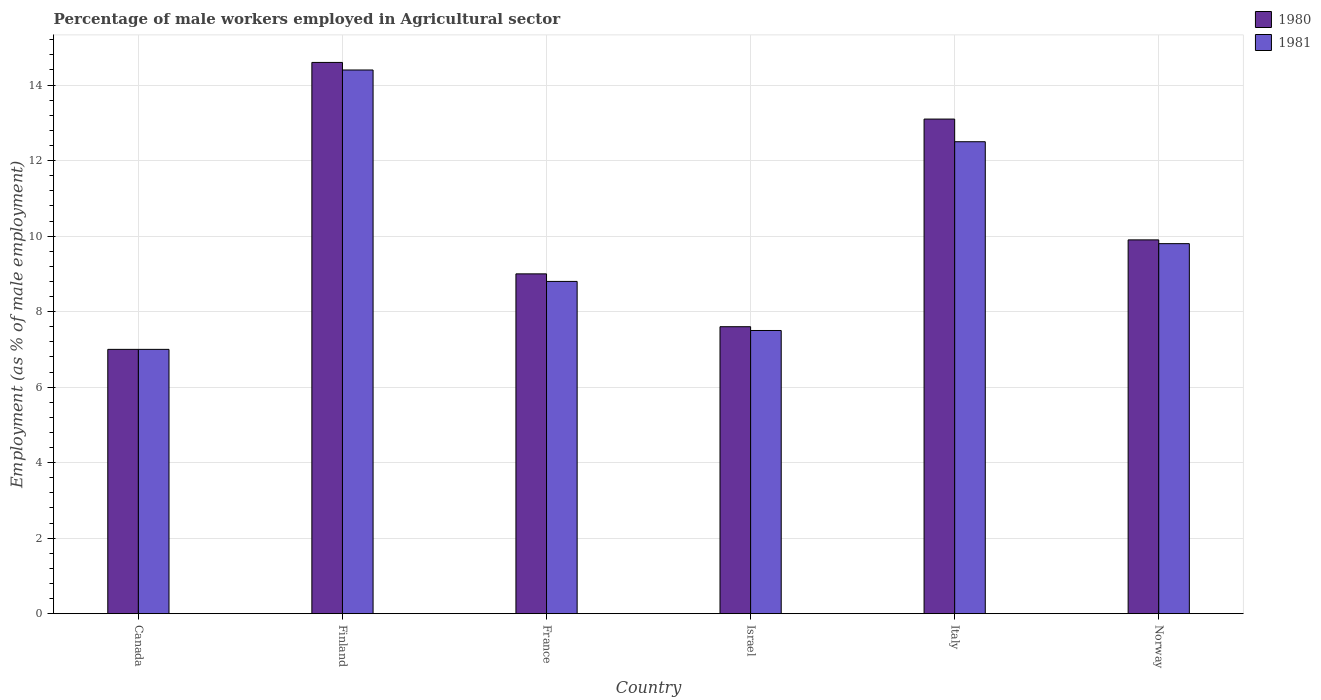Are the number of bars on each tick of the X-axis equal?
Your answer should be compact. Yes. How many bars are there on the 3rd tick from the left?
Keep it short and to the point. 2. How many bars are there on the 6th tick from the right?
Make the answer very short. 2. What is the label of the 5th group of bars from the left?
Provide a succinct answer. Italy. What is the percentage of male workers employed in Agricultural sector in 1980 in Norway?
Ensure brevity in your answer.  9.9. Across all countries, what is the maximum percentage of male workers employed in Agricultural sector in 1980?
Your response must be concise. 14.6. What is the total percentage of male workers employed in Agricultural sector in 1980 in the graph?
Keep it short and to the point. 61.2. What is the difference between the percentage of male workers employed in Agricultural sector in 1980 in Israel and that in Italy?
Provide a succinct answer. -5.5. What is the difference between the percentage of male workers employed in Agricultural sector in 1980 in Norway and the percentage of male workers employed in Agricultural sector in 1981 in Canada?
Your answer should be compact. 2.9. What is the average percentage of male workers employed in Agricultural sector in 1980 per country?
Provide a short and direct response. 10.2. What is the difference between the percentage of male workers employed in Agricultural sector of/in 1981 and percentage of male workers employed in Agricultural sector of/in 1980 in Italy?
Ensure brevity in your answer.  -0.6. What is the ratio of the percentage of male workers employed in Agricultural sector in 1981 in Canada to that in Norway?
Provide a short and direct response. 0.71. Is the percentage of male workers employed in Agricultural sector in 1981 in Israel less than that in Italy?
Offer a terse response. Yes. Is the difference between the percentage of male workers employed in Agricultural sector in 1981 in Canada and Finland greater than the difference between the percentage of male workers employed in Agricultural sector in 1980 in Canada and Finland?
Ensure brevity in your answer.  Yes. What is the difference between the highest and the second highest percentage of male workers employed in Agricultural sector in 1981?
Give a very brief answer. -2.7. What is the difference between the highest and the lowest percentage of male workers employed in Agricultural sector in 1981?
Your answer should be very brief. 7.4. In how many countries, is the percentage of male workers employed in Agricultural sector in 1980 greater than the average percentage of male workers employed in Agricultural sector in 1980 taken over all countries?
Provide a short and direct response. 2. What does the 2nd bar from the right in Canada represents?
Your answer should be very brief. 1980. How many bars are there?
Keep it short and to the point. 12. Are all the bars in the graph horizontal?
Offer a terse response. No. How many countries are there in the graph?
Your answer should be compact. 6. What is the difference between two consecutive major ticks on the Y-axis?
Your response must be concise. 2. Are the values on the major ticks of Y-axis written in scientific E-notation?
Your response must be concise. No. Does the graph contain any zero values?
Make the answer very short. No. Does the graph contain grids?
Your response must be concise. Yes. Where does the legend appear in the graph?
Your answer should be very brief. Top right. What is the title of the graph?
Keep it short and to the point. Percentage of male workers employed in Agricultural sector. What is the label or title of the Y-axis?
Provide a succinct answer. Employment (as % of male employment). What is the Employment (as % of male employment) in 1981 in Canada?
Give a very brief answer. 7. What is the Employment (as % of male employment) in 1980 in Finland?
Keep it short and to the point. 14.6. What is the Employment (as % of male employment) in 1981 in Finland?
Ensure brevity in your answer.  14.4. What is the Employment (as % of male employment) of 1980 in France?
Your answer should be compact. 9. What is the Employment (as % of male employment) of 1981 in France?
Your answer should be very brief. 8.8. What is the Employment (as % of male employment) in 1980 in Israel?
Ensure brevity in your answer.  7.6. What is the Employment (as % of male employment) in 1980 in Italy?
Your answer should be compact. 13.1. What is the Employment (as % of male employment) in 1981 in Italy?
Make the answer very short. 12.5. What is the Employment (as % of male employment) of 1980 in Norway?
Provide a short and direct response. 9.9. What is the Employment (as % of male employment) in 1981 in Norway?
Offer a very short reply. 9.8. Across all countries, what is the maximum Employment (as % of male employment) in 1980?
Make the answer very short. 14.6. Across all countries, what is the maximum Employment (as % of male employment) in 1981?
Provide a short and direct response. 14.4. What is the total Employment (as % of male employment) in 1980 in the graph?
Provide a short and direct response. 61.2. What is the total Employment (as % of male employment) of 1981 in the graph?
Provide a short and direct response. 60. What is the difference between the Employment (as % of male employment) in 1980 in Canada and that in France?
Provide a short and direct response. -2. What is the difference between the Employment (as % of male employment) of 1981 in Canada and that in France?
Your answer should be very brief. -1.8. What is the difference between the Employment (as % of male employment) of 1980 in Canada and that in Israel?
Your response must be concise. -0.6. What is the difference between the Employment (as % of male employment) of 1981 in Canada and that in Israel?
Your answer should be compact. -0.5. What is the difference between the Employment (as % of male employment) in 1981 in Canada and that in Norway?
Provide a succinct answer. -2.8. What is the difference between the Employment (as % of male employment) in 1980 in Finland and that in France?
Ensure brevity in your answer.  5.6. What is the difference between the Employment (as % of male employment) of 1981 in Finland and that in Israel?
Your response must be concise. 6.9. What is the difference between the Employment (as % of male employment) in 1980 in France and that in Israel?
Your response must be concise. 1.4. What is the difference between the Employment (as % of male employment) of 1981 in France and that in Israel?
Your answer should be very brief. 1.3. What is the difference between the Employment (as % of male employment) in 1980 in France and that in Italy?
Your answer should be very brief. -4.1. What is the difference between the Employment (as % of male employment) in 1980 in France and that in Norway?
Offer a very short reply. -0.9. What is the difference between the Employment (as % of male employment) in 1981 in Israel and that in Italy?
Your answer should be compact. -5. What is the difference between the Employment (as % of male employment) of 1980 in Israel and that in Norway?
Provide a succinct answer. -2.3. What is the difference between the Employment (as % of male employment) in 1981 in Israel and that in Norway?
Provide a succinct answer. -2.3. What is the difference between the Employment (as % of male employment) of 1981 in Italy and that in Norway?
Make the answer very short. 2.7. What is the difference between the Employment (as % of male employment) of 1980 in Canada and the Employment (as % of male employment) of 1981 in Italy?
Your answer should be very brief. -5.5. What is the difference between the Employment (as % of male employment) of 1980 in Finland and the Employment (as % of male employment) of 1981 in France?
Your answer should be very brief. 5.8. What is the difference between the Employment (as % of male employment) of 1980 in Finland and the Employment (as % of male employment) of 1981 in Israel?
Give a very brief answer. 7.1. What is the difference between the Employment (as % of male employment) in 1980 in France and the Employment (as % of male employment) in 1981 in Israel?
Offer a terse response. 1.5. What is the difference between the Employment (as % of male employment) in 1980 in France and the Employment (as % of male employment) in 1981 in Italy?
Provide a short and direct response. -3.5. What is the difference between the Employment (as % of male employment) of 1980 in France and the Employment (as % of male employment) of 1981 in Norway?
Provide a succinct answer. -0.8. What is the difference between the Employment (as % of male employment) in 1980 in Israel and the Employment (as % of male employment) in 1981 in Italy?
Offer a very short reply. -4.9. What is the difference between the Employment (as % of male employment) of 1980 in Israel and the Employment (as % of male employment) of 1981 in Norway?
Keep it short and to the point. -2.2. What is the difference between the Employment (as % of male employment) of 1980 and Employment (as % of male employment) of 1981 in Canada?
Your answer should be compact. 0. What is the difference between the Employment (as % of male employment) in 1980 and Employment (as % of male employment) in 1981 in Italy?
Provide a succinct answer. 0.6. What is the difference between the Employment (as % of male employment) in 1980 and Employment (as % of male employment) in 1981 in Norway?
Ensure brevity in your answer.  0.1. What is the ratio of the Employment (as % of male employment) of 1980 in Canada to that in Finland?
Your answer should be very brief. 0.48. What is the ratio of the Employment (as % of male employment) in 1981 in Canada to that in Finland?
Offer a terse response. 0.49. What is the ratio of the Employment (as % of male employment) in 1980 in Canada to that in France?
Make the answer very short. 0.78. What is the ratio of the Employment (as % of male employment) of 1981 in Canada to that in France?
Your answer should be very brief. 0.8. What is the ratio of the Employment (as % of male employment) in 1980 in Canada to that in Israel?
Your response must be concise. 0.92. What is the ratio of the Employment (as % of male employment) of 1981 in Canada to that in Israel?
Make the answer very short. 0.93. What is the ratio of the Employment (as % of male employment) of 1980 in Canada to that in Italy?
Keep it short and to the point. 0.53. What is the ratio of the Employment (as % of male employment) in 1981 in Canada to that in Italy?
Ensure brevity in your answer.  0.56. What is the ratio of the Employment (as % of male employment) in 1980 in Canada to that in Norway?
Provide a succinct answer. 0.71. What is the ratio of the Employment (as % of male employment) in 1980 in Finland to that in France?
Your answer should be compact. 1.62. What is the ratio of the Employment (as % of male employment) in 1981 in Finland to that in France?
Make the answer very short. 1.64. What is the ratio of the Employment (as % of male employment) in 1980 in Finland to that in Israel?
Offer a very short reply. 1.92. What is the ratio of the Employment (as % of male employment) of 1981 in Finland to that in Israel?
Ensure brevity in your answer.  1.92. What is the ratio of the Employment (as % of male employment) in 1980 in Finland to that in Italy?
Give a very brief answer. 1.11. What is the ratio of the Employment (as % of male employment) in 1981 in Finland to that in Italy?
Provide a succinct answer. 1.15. What is the ratio of the Employment (as % of male employment) of 1980 in Finland to that in Norway?
Offer a very short reply. 1.47. What is the ratio of the Employment (as % of male employment) of 1981 in Finland to that in Norway?
Give a very brief answer. 1.47. What is the ratio of the Employment (as % of male employment) in 1980 in France to that in Israel?
Ensure brevity in your answer.  1.18. What is the ratio of the Employment (as % of male employment) of 1981 in France to that in Israel?
Make the answer very short. 1.17. What is the ratio of the Employment (as % of male employment) in 1980 in France to that in Italy?
Ensure brevity in your answer.  0.69. What is the ratio of the Employment (as % of male employment) of 1981 in France to that in Italy?
Your response must be concise. 0.7. What is the ratio of the Employment (as % of male employment) of 1981 in France to that in Norway?
Offer a terse response. 0.9. What is the ratio of the Employment (as % of male employment) of 1980 in Israel to that in Italy?
Offer a very short reply. 0.58. What is the ratio of the Employment (as % of male employment) in 1981 in Israel to that in Italy?
Provide a succinct answer. 0.6. What is the ratio of the Employment (as % of male employment) of 1980 in Israel to that in Norway?
Your answer should be compact. 0.77. What is the ratio of the Employment (as % of male employment) of 1981 in Israel to that in Norway?
Offer a very short reply. 0.77. What is the ratio of the Employment (as % of male employment) of 1980 in Italy to that in Norway?
Your response must be concise. 1.32. What is the ratio of the Employment (as % of male employment) of 1981 in Italy to that in Norway?
Keep it short and to the point. 1.28. What is the difference between the highest and the lowest Employment (as % of male employment) in 1981?
Provide a short and direct response. 7.4. 